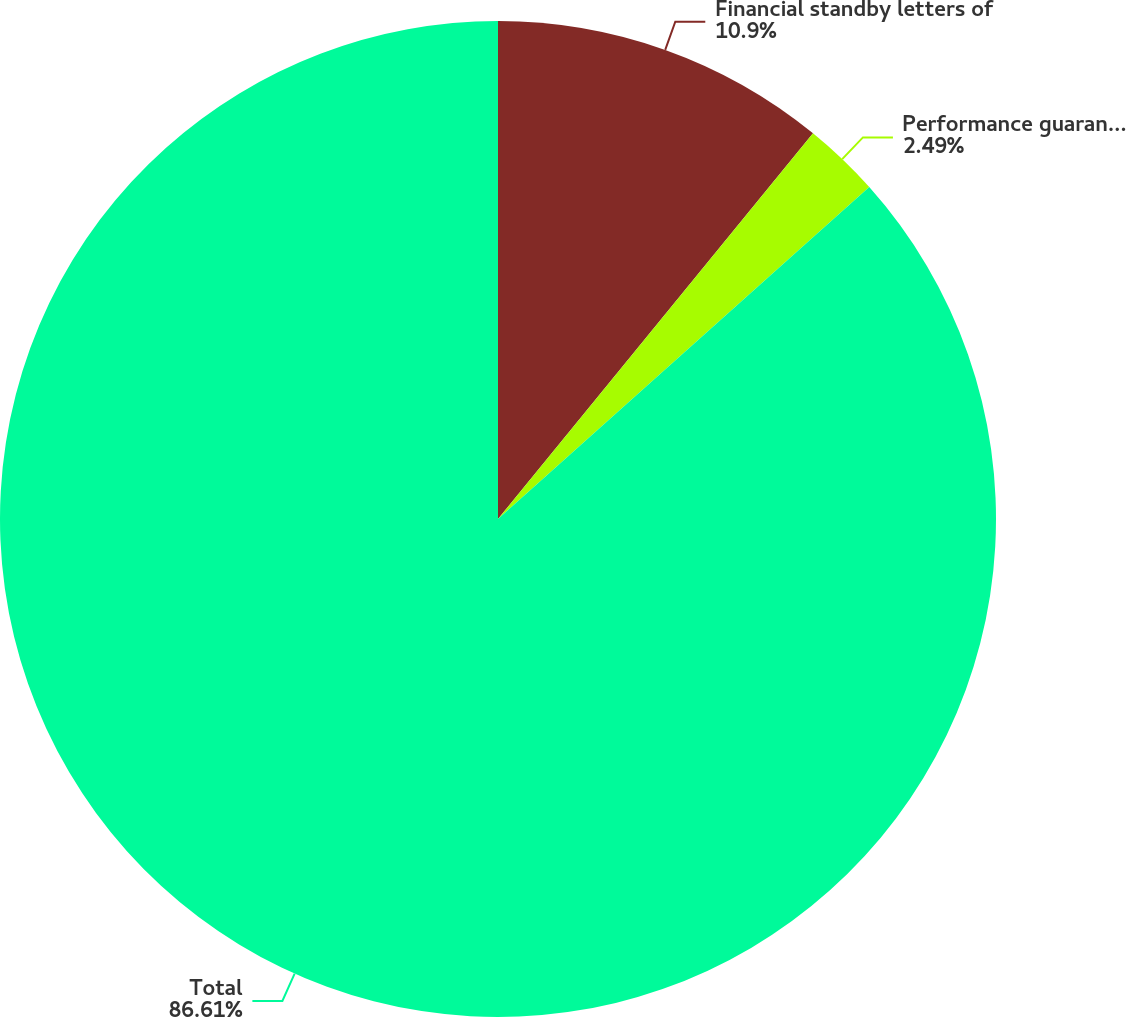Convert chart. <chart><loc_0><loc_0><loc_500><loc_500><pie_chart><fcel>Financial standby letters of<fcel>Performance guarantees<fcel>Total<nl><fcel>10.9%<fcel>2.49%<fcel>86.61%<nl></chart> 